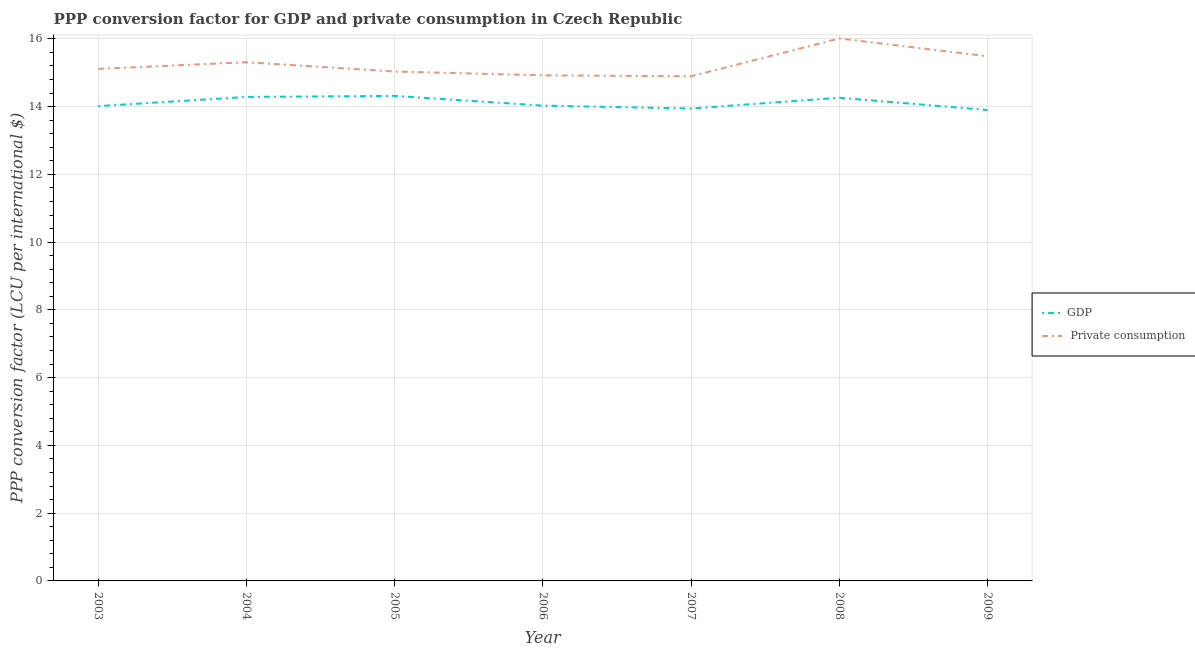Is the number of lines equal to the number of legend labels?
Offer a terse response. Yes. What is the ppp conversion factor for gdp in 2003?
Make the answer very short. 14.01. Across all years, what is the maximum ppp conversion factor for gdp?
Your answer should be compact. 14.32. Across all years, what is the minimum ppp conversion factor for gdp?
Ensure brevity in your answer.  13.9. In which year was the ppp conversion factor for gdp maximum?
Provide a succinct answer. 2005. In which year was the ppp conversion factor for gdp minimum?
Offer a very short reply. 2009. What is the total ppp conversion factor for gdp in the graph?
Your answer should be very brief. 98.75. What is the difference between the ppp conversion factor for gdp in 2005 and that in 2007?
Offer a terse response. 0.37. What is the difference between the ppp conversion factor for gdp in 2003 and the ppp conversion factor for private consumption in 2005?
Keep it short and to the point. -1.02. What is the average ppp conversion factor for private consumption per year?
Your response must be concise. 15.25. In the year 2005, what is the difference between the ppp conversion factor for private consumption and ppp conversion factor for gdp?
Give a very brief answer. 0.72. What is the ratio of the ppp conversion factor for gdp in 2006 to that in 2008?
Make the answer very short. 0.98. Is the ppp conversion factor for private consumption in 2004 less than that in 2008?
Offer a very short reply. Yes. What is the difference between the highest and the second highest ppp conversion factor for gdp?
Your response must be concise. 0.03. What is the difference between the highest and the lowest ppp conversion factor for private consumption?
Make the answer very short. 1.12. Is the ppp conversion factor for gdp strictly less than the ppp conversion factor for private consumption over the years?
Provide a short and direct response. Yes. How many lines are there?
Your answer should be compact. 2. How many years are there in the graph?
Your response must be concise. 7. What is the difference between two consecutive major ticks on the Y-axis?
Offer a very short reply. 2. Does the graph contain any zero values?
Offer a very short reply. No. Where does the legend appear in the graph?
Your answer should be very brief. Center right. What is the title of the graph?
Provide a short and direct response. PPP conversion factor for GDP and private consumption in Czech Republic. Does "Birth rate" appear as one of the legend labels in the graph?
Offer a very short reply. No. What is the label or title of the X-axis?
Make the answer very short. Year. What is the label or title of the Y-axis?
Offer a very short reply. PPP conversion factor (LCU per international $). What is the PPP conversion factor (LCU per international $) of GDP in 2003?
Provide a succinct answer. 14.01. What is the PPP conversion factor (LCU per international $) in  Private consumption in 2003?
Provide a succinct answer. 15.11. What is the PPP conversion factor (LCU per international $) of GDP in 2004?
Keep it short and to the point. 14.29. What is the PPP conversion factor (LCU per international $) of  Private consumption in 2004?
Your answer should be very brief. 15.31. What is the PPP conversion factor (LCU per international $) of GDP in 2005?
Ensure brevity in your answer.  14.32. What is the PPP conversion factor (LCU per international $) of  Private consumption in 2005?
Offer a very short reply. 15.04. What is the PPP conversion factor (LCU per international $) in GDP in 2006?
Keep it short and to the point. 14.03. What is the PPP conversion factor (LCU per international $) of  Private consumption in 2006?
Give a very brief answer. 14.92. What is the PPP conversion factor (LCU per international $) of GDP in 2007?
Provide a short and direct response. 13.94. What is the PPP conversion factor (LCU per international $) in  Private consumption in 2007?
Provide a succinct answer. 14.9. What is the PPP conversion factor (LCU per international $) in GDP in 2008?
Make the answer very short. 14.26. What is the PPP conversion factor (LCU per international $) in  Private consumption in 2008?
Your answer should be compact. 16.01. What is the PPP conversion factor (LCU per international $) in GDP in 2009?
Your answer should be very brief. 13.9. What is the PPP conversion factor (LCU per international $) in  Private consumption in 2009?
Offer a very short reply. 15.48. Across all years, what is the maximum PPP conversion factor (LCU per international $) in GDP?
Make the answer very short. 14.32. Across all years, what is the maximum PPP conversion factor (LCU per international $) in  Private consumption?
Offer a very short reply. 16.01. Across all years, what is the minimum PPP conversion factor (LCU per international $) in GDP?
Provide a succinct answer. 13.9. Across all years, what is the minimum PPP conversion factor (LCU per international $) of  Private consumption?
Keep it short and to the point. 14.9. What is the total PPP conversion factor (LCU per international $) in GDP in the graph?
Make the answer very short. 98.75. What is the total PPP conversion factor (LCU per international $) of  Private consumption in the graph?
Ensure brevity in your answer.  106.77. What is the difference between the PPP conversion factor (LCU per international $) in GDP in 2003 and that in 2004?
Provide a succinct answer. -0.27. What is the difference between the PPP conversion factor (LCU per international $) of  Private consumption in 2003 and that in 2004?
Offer a very short reply. -0.2. What is the difference between the PPP conversion factor (LCU per international $) of GDP in 2003 and that in 2005?
Ensure brevity in your answer.  -0.3. What is the difference between the PPP conversion factor (LCU per international $) in  Private consumption in 2003 and that in 2005?
Ensure brevity in your answer.  0.08. What is the difference between the PPP conversion factor (LCU per international $) of GDP in 2003 and that in 2006?
Your answer should be compact. -0.01. What is the difference between the PPP conversion factor (LCU per international $) in  Private consumption in 2003 and that in 2006?
Give a very brief answer. 0.19. What is the difference between the PPP conversion factor (LCU per international $) in GDP in 2003 and that in 2007?
Make the answer very short. 0.07. What is the difference between the PPP conversion factor (LCU per international $) of  Private consumption in 2003 and that in 2007?
Offer a very short reply. 0.22. What is the difference between the PPP conversion factor (LCU per international $) of GDP in 2003 and that in 2008?
Ensure brevity in your answer.  -0.25. What is the difference between the PPP conversion factor (LCU per international $) in  Private consumption in 2003 and that in 2008?
Give a very brief answer. -0.9. What is the difference between the PPP conversion factor (LCU per international $) of GDP in 2003 and that in 2009?
Ensure brevity in your answer.  0.12. What is the difference between the PPP conversion factor (LCU per international $) in  Private consumption in 2003 and that in 2009?
Offer a very short reply. -0.37. What is the difference between the PPP conversion factor (LCU per international $) in GDP in 2004 and that in 2005?
Provide a short and direct response. -0.03. What is the difference between the PPP conversion factor (LCU per international $) in  Private consumption in 2004 and that in 2005?
Provide a succinct answer. 0.27. What is the difference between the PPP conversion factor (LCU per international $) of GDP in 2004 and that in 2006?
Provide a short and direct response. 0.26. What is the difference between the PPP conversion factor (LCU per international $) in  Private consumption in 2004 and that in 2006?
Your response must be concise. 0.39. What is the difference between the PPP conversion factor (LCU per international $) of GDP in 2004 and that in 2007?
Your response must be concise. 0.34. What is the difference between the PPP conversion factor (LCU per international $) of  Private consumption in 2004 and that in 2007?
Your answer should be very brief. 0.41. What is the difference between the PPP conversion factor (LCU per international $) in GDP in 2004 and that in 2008?
Ensure brevity in your answer.  0.02. What is the difference between the PPP conversion factor (LCU per international $) of  Private consumption in 2004 and that in 2008?
Provide a short and direct response. -0.7. What is the difference between the PPP conversion factor (LCU per international $) in GDP in 2004 and that in 2009?
Provide a succinct answer. 0.39. What is the difference between the PPP conversion factor (LCU per international $) of  Private consumption in 2004 and that in 2009?
Give a very brief answer. -0.17. What is the difference between the PPP conversion factor (LCU per international $) of GDP in 2005 and that in 2006?
Offer a very short reply. 0.29. What is the difference between the PPP conversion factor (LCU per international $) in  Private consumption in 2005 and that in 2006?
Give a very brief answer. 0.11. What is the difference between the PPP conversion factor (LCU per international $) in GDP in 2005 and that in 2007?
Make the answer very short. 0.37. What is the difference between the PPP conversion factor (LCU per international $) in  Private consumption in 2005 and that in 2007?
Your response must be concise. 0.14. What is the difference between the PPP conversion factor (LCU per international $) in GDP in 2005 and that in 2008?
Provide a short and direct response. 0.05. What is the difference between the PPP conversion factor (LCU per international $) in  Private consumption in 2005 and that in 2008?
Your response must be concise. -0.98. What is the difference between the PPP conversion factor (LCU per international $) of GDP in 2005 and that in 2009?
Keep it short and to the point. 0.42. What is the difference between the PPP conversion factor (LCU per international $) of  Private consumption in 2005 and that in 2009?
Give a very brief answer. -0.45. What is the difference between the PPP conversion factor (LCU per international $) in GDP in 2006 and that in 2007?
Offer a terse response. 0.09. What is the difference between the PPP conversion factor (LCU per international $) in  Private consumption in 2006 and that in 2007?
Your response must be concise. 0.03. What is the difference between the PPP conversion factor (LCU per international $) in GDP in 2006 and that in 2008?
Your answer should be compact. -0.23. What is the difference between the PPP conversion factor (LCU per international $) of  Private consumption in 2006 and that in 2008?
Provide a short and direct response. -1.09. What is the difference between the PPP conversion factor (LCU per international $) in GDP in 2006 and that in 2009?
Make the answer very short. 0.13. What is the difference between the PPP conversion factor (LCU per international $) of  Private consumption in 2006 and that in 2009?
Provide a short and direct response. -0.56. What is the difference between the PPP conversion factor (LCU per international $) of GDP in 2007 and that in 2008?
Give a very brief answer. -0.32. What is the difference between the PPP conversion factor (LCU per international $) of  Private consumption in 2007 and that in 2008?
Give a very brief answer. -1.12. What is the difference between the PPP conversion factor (LCU per international $) of GDP in 2007 and that in 2009?
Make the answer very short. 0.04. What is the difference between the PPP conversion factor (LCU per international $) of  Private consumption in 2007 and that in 2009?
Give a very brief answer. -0.59. What is the difference between the PPP conversion factor (LCU per international $) in GDP in 2008 and that in 2009?
Provide a succinct answer. 0.36. What is the difference between the PPP conversion factor (LCU per international $) in  Private consumption in 2008 and that in 2009?
Make the answer very short. 0.53. What is the difference between the PPP conversion factor (LCU per international $) of GDP in 2003 and the PPP conversion factor (LCU per international $) of  Private consumption in 2004?
Provide a short and direct response. -1.3. What is the difference between the PPP conversion factor (LCU per international $) of GDP in 2003 and the PPP conversion factor (LCU per international $) of  Private consumption in 2005?
Your response must be concise. -1.02. What is the difference between the PPP conversion factor (LCU per international $) of GDP in 2003 and the PPP conversion factor (LCU per international $) of  Private consumption in 2006?
Your answer should be compact. -0.91. What is the difference between the PPP conversion factor (LCU per international $) of GDP in 2003 and the PPP conversion factor (LCU per international $) of  Private consumption in 2007?
Your response must be concise. -0.88. What is the difference between the PPP conversion factor (LCU per international $) of GDP in 2003 and the PPP conversion factor (LCU per international $) of  Private consumption in 2008?
Make the answer very short. -2. What is the difference between the PPP conversion factor (LCU per international $) in GDP in 2003 and the PPP conversion factor (LCU per international $) in  Private consumption in 2009?
Keep it short and to the point. -1.47. What is the difference between the PPP conversion factor (LCU per international $) of GDP in 2004 and the PPP conversion factor (LCU per international $) of  Private consumption in 2005?
Ensure brevity in your answer.  -0.75. What is the difference between the PPP conversion factor (LCU per international $) in GDP in 2004 and the PPP conversion factor (LCU per international $) in  Private consumption in 2006?
Offer a very short reply. -0.64. What is the difference between the PPP conversion factor (LCU per international $) of GDP in 2004 and the PPP conversion factor (LCU per international $) of  Private consumption in 2007?
Make the answer very short. -0.61. What is the difference between the PPP conversion factor (LCU per international $) in GDP in 2004 and the PPP conversion factor (LCU per international $) in  Private consumption in 2008?
Keep it short and to the point. -1.73. What is the difference between the PPP conversion factor (LCU per international $) of GDP in 2004 and the PPP conversion factor (LCU per international $) of  Private consumption in 2009?
Offer a terse response. -1.2. What is the difference between the PPP conversion factor (LCU per international $) of GDP in 2005 and the PPP conversion factor (LCU per international $) of  Private consumption in 2006?
Provide a succinct answer. -0.61. What is the difference between the PPP conversion factor (LCU per international $) in GDP in 2005 and the PPP conversion factor (LCU per international $) in  Private consumption in 2007?
Provide a short and direct response. -0.58. What is the difference between the PPP conversion factor (LCU per international $) in GDP in 2005 and the PPP conversion factor (LCU per international $) in  Private consumption in 2008?
Offer a terse response. -1.7. What is the difference between the PPP conversion factor (LCU per international $) in GDP in 2005 and the PPP conversion factor (LCU per international $) in  Private consumption in 2009?
Your answer should be compact. -1.17. What is the difference between the PPP conversion factor (LCU per international $) in GDP in 2006 and the PPP conversion factor (LCU per international $) in  Private consumption in 2007?
Make the answer very short. -0.87. What is the difference between the PPP conversion factor (LCU per international $) of GDP in 2006 and the PPP conversion factor (LCU per international $) of  Private consumption in 2008?
Give a very brief answer. -1.98. What is the difference between the PPP conversion factor (LCU per international $) of GDP in 2006 and the PPP conversion factor (LCU per international $) of  Private consumption in 2009?
Keep it short and to the point. -1.46. What is the difference between the PPP conversion factor (LCU per international $) of GDP in 2007 and the PPP conversion factor (LCU per international $) of  Private consumption in 2008?
Your answer should be very brief. -2.07. What is the difference between the PPP conversion factor (LCU per international $) in GDP in 2007 and the PPP conversion factor (LCU per international $) in  Private consumption in 2009?
Keep it short and to the point. -1.54. What is the difference between the PPP conversion factor (LCU per international $) in GDP in 2008 and the PPP conversion factor (LCU per international $) in  Private consumption in 2009?
Give a very brief answer. -1.22. What is the average PPP conversion factor (LCU per international $) of GDP per year?
Offer a very short reply. 14.11. What is the average PPP conversion factor (LCU per international $) in  Private consumption per year?
Ensure brevity in your answer.  15.25. In the year 2003, what is the difference between the PPP conversion factor (LCU per international $) of GDP and PPP conversion factor (LCU per international $) of  Private consumption?
Offer a terse response. -1.1. In the year 2004, what is the difference between the PPP conversion factor (LCU per international $) of GDP and PPP conversion factor (LCU per international $) of  Private consumption?
Keep it short and to the point. -1.02. In the year 2005, what is the difference between the PPP conversion factor (LCU per international $) in GDP and PPP conversion factor (LCU per international $) in  Private consumption?
Give a very brief answer. -0.72. In the year 2006, what is the difference between the PPP conversion factor (LCU per international $) of GDP and PPP conversion factor (LCU per international $) of  Private consumption?
Give a very brief answer. -0.89. In the year 2007, what is the difference between the PPP conversion factor (LCU per international $) of GDP and PPP conversion factor (LCU per international $) of  Private consumption?
Your answer should be compact. -0.95. In the year 2008, what is the difference between the PPP conversion factor (LCU per international $) in GDP and PPP conversion factor (LCU per international $) in  Private consumption?
Make the answer very short. -1.75. In the year 2009, what is the difference between the PPP conversion factor (LCU per international $) in GDP and PPP conversion factor (LCU per international $) in  Private consumption?
Offer a terse response. -1.59. What is the ratio of the PPP conversion factor (LCU per international $) of GDP in 2003 to that in 2004?
Keep it short and to the point. 0.98. What is the ratio of the PPP conversion factor (LCU per international $) of  Private consumption in 2003 to that in 2004?
Ensure brevity in your answer.  0.99. What is the ratio of the PPP conversion factor (LCU per international $) in GDP in 2003 to that in 2005?
Make the answer very short. 0.98. What is the ratio of the PPP conversion factor (LCU per international $) in GDP in 2003 to that in 2006?
Offer a very short reply. 1. What is the ratio of the PPP conversion factor (LCU per international $) in  Private consumption in 2003 to that in 2006?
Make the answer very short. 1.01. What is the ratio of the PPP conversion factor (LCU per international $) in  Private consumption in 2003 to that in 2007?
Offer a terse response. 1.01. What is the ratio of the PPP conversion factor (LCU per international $) in GDP in 2003 to that in 2008?
Offer a very short reply. 0.98. What is the ratio of the PPP conversion factor (LCU per international $) in  Private consumption in 2003 to that in 2008?
Ensure brevity in your answer.  0.94. What is the ratio of the PPP conversion factor (LCU per international $) in GDP in 2003 to that in 2009?
Make the answer very short. 1.01. What is the ratio of the PPP conversion factor (LCU per international $) in  Private consumption in 2003 to that in 2009?
Your response must be concise. 0.98. What is the ratio of the PPP conversion factor (LCU per international $) of  Private consumption in 2004 to that in 2005?
Offer a terse response. 1.02. What is the ratio of the PPP conversion factor (LCU per international $) in GDP in 2004 to that in 2006?
Offer a terse response. 1.02. What is the ratio of the PPP conversion factor (LCU per international $) in  Private consumption in 2004 to that in 2006?
Provide a short and direct response. 1.03. What is the ratio of the PPP conversion factor (LCU per international $) in GDP in 2004 to that in 2007?
Provide a short and direct response. 1.02. What is the ratio of the PPP conversion factor (LCU per international $) in  Private consumption in 2004 to that in 2007?
Provide a short and direct response. 1.03. What is the ratio of the PPP conversion factor (LCU per international $) of GDP in 2004 to that in 2008?
Your answer should be very brief. 1. What is the ratio of the PPP conversion factor (LCU per international $) of  Private consumption in 2004 to that in 2008?
Offer a very short reply. 0.96. What is the ratio of the PPP conversion factor (LCU per international $) in GDP in 2004 to that in 2009?
Provide a succinct answer. 1.03. What is the ratio of the PPP conversion factor (LCU per international $) of  Private consumption in 2004 to that in 2009?
Provide a short and direct response. 0.99. What is the ratio of the PPP conversion factor (LCU per international $) of GDP in 2005 to that in 2006?
Keep it short and to the point. 1.02. What is the ratio of the PPP conversion factor (LCU per international $) of  Private consumption in 2005 to that in 2006?
Make the answer very short. 1.01. What is the ratio of the PPP conversion factor (LCU per international $) in GDP in 2005 to that in 2007?
Your response must be concise. 1.03. What is the ratio of the PPP conversion factor (LCU per international $) of  Private consumption in 2005 to that in 2007?
Offer a very short reply. 1.01. What is the ratio of the PPP conversion factor (LCU per international $) of  Private consumption in 2005 to that in 2008?
Keep it short and to the point. 0.94. What is the ratio of the PPP conversion factor (LCU per international $) in  Private consumption in 2005 to that in 2009?
Your answer should be compact. 0.97. What is the ratio of the PPP conversion factor (LCU per international $) of  Private consumption in 2006 to that in 2007?
Your answer should be compact. 1. What is the ratio of the PPP conversion factor (LCU per international $) of GDP in 2006 to that in 2008?
Give a very brief answer. 0.98. What is the ratio of the PPP conversion factor (LCU per international $) of  Private consumption in 2006 to that in 2008?
Make the answer very short. 0.93. What is the ratio of the PPP conversion factor (LCU per international $) in GDP in 2006 to that in 2009?
Provide a succinct answer. 1.01. What is the ratio of the PPP conversion factor (LCU per international $) of  Private consumption in 2006 to that in 2009?
Ensure brevity in your answer.  0.96. What is the ratio of the PPP conversion factor (LCU per international $) of GDP in 2007 to that in 2008?
Ensure brevity in your answer.  0.98. What is the ratio of the PPP conversion factor (LCU per international $) in  Private consumption in 2007 to that in 2008?
Your answer should be very brief. 0.93. What is the ratio of the PPP conversion factor (LCU per international $) of GDP in 2008 to that in 2009?
Ensure brevity in your answer.  1.03. What is the ratio of the PPP conversion factor (LCU per international $) of  Private consumption in 2008 to that in 2009?
Offer a very short reply. 1.03. What is the difference between the highest and the second highest PPP conversion factor (LCU per international $) of GDP?
Ensure brevity in your answer.  0.03. What is the difference between the highest and the second highest PPP conversion factor (LCU per international $) in  Private consumption?
Your answer should be compact. 0.53. What is the difference between the highest and the lowest PPP conversion factor (LCU per international $) of GDP?
Give a very brief answer. 0.42. What is the difference between the highest and the lowest PPP conversion factor (LCU per international $) in  Private consumption?
Offer a terse response. 1.12. 